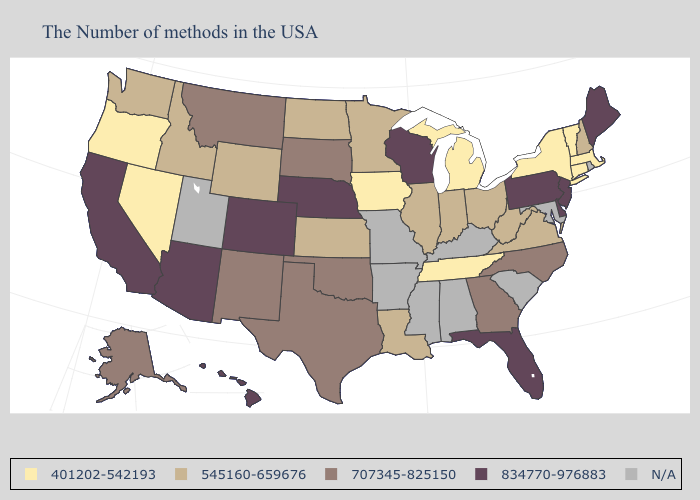Name the states that have a value in the range 834770-976883?
Be succinct. Maine, New Jersey, Delaware, Pennsylvania, Florida, Wisconsin, Nebraska, Colorado, Arizona, California, Hawaii. Name the states that have a value in the range 834770-976883?
Keep it brief. Maine, New Jersey, Delaware, Pennsylvania, Florida, Wisconsin, Nebraska, Colorado, Arizona, California, Hawaii. What is the highest value in the South ?
Keep it brief. 834770-976883. What is the value of New Mexico?
Concise answer only. 707345-825150. Does Louisiana have the highest value in the South?
Quick response, please. No. Which states have the highest value in the USA?
Answer briefly. Maine, New Jersey, Delaware, Pennsylvania, Florida, Wisconsin, Nebraska, Colorado, Arizona, California, Hawaii. What is the value of Iowa?
Answer briefly. 401202-542193. Does West Virginia have the lowest value in the South?
Answer briefly. No. Which states hav the highest value in the MidWest?
Keep it brief. Wisconsin, Nebraska. Does the map have missing data?
Be succinct. Yes. Among the states that border Arizona , does Colorado have the highest value?
Answer briefly. Yes. Among the states that border Ohio , does West Virginia have the highest value?
Write a very short answer. No. What is the value of New York?
Write a very short answer. 401202-542193. Does Florida have the lowest value in the South?
Keep it brief. No. Does Pennsylvania have the highest value in the USA?
Keep it brief. Yes. 